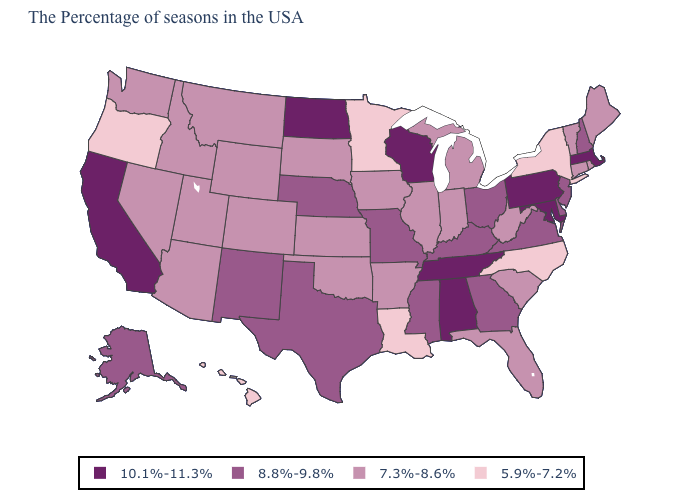Does Illinois have the same value as Florida?
Write a very short answer. Yes. What is the value of New Jersey?
Answer briefly. 8.8%-9.8%. What is the value of Tennessee?
Write a very short answer. 10.1%-11.3%. Does Minnesota have a lower value than Georgia?
Short answer required. Yes. What is the value of Michigan?
Short answer required. 7.3%-8.6%. Does Colorado have a lower value than Kentucky?
Quick response, please. Yes. What is the lowest value in states that border Minnesota?
Concise answer only. 7.3%-8.6%. What is the lowest value in the MidWest?
Concise answer only. 5.9%-7.2%. Does Maryland have the highest value in the USA?
Answer briefly. Yes. What is the value of New Jersey?
Keep it brief. 8.8%-9.8%. What is the value of Mississippi?
Concise answer only. 8.8%-9.8%. Which states have the lowest value in the USA?
Concise answer only. New York, North Carolina, Louisiana, Minnesota, Oregon, Hawaii. Does Oregon have the lowest value in the USA?
Be succinct. Yes. What is the value of North Carolina?
Give a very brief answer. 5.9%-7.2%. Does Montana have the same value as Massachusetts?
Answer briefly. No. 